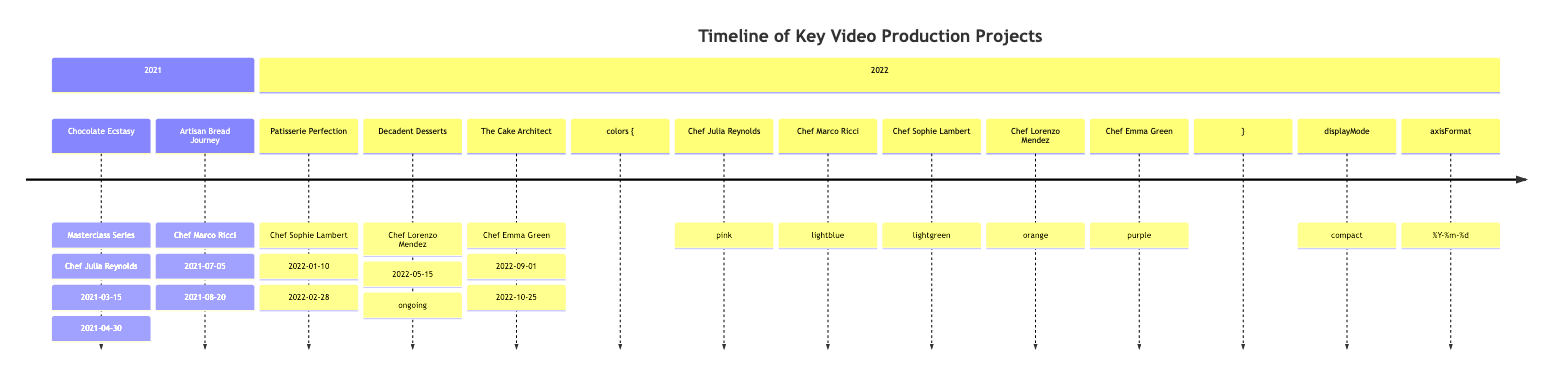what was the first project listed in the timeline? The timeline starts with the project "Chocolate Ecstasy: Masterclass Series" which is the first entry in the data provided.
Answer: Chocolate Ecstasy: Masterclass Series how many clients are represented in the timeline? The timeline lists five distinct projects, each associated with a different client. The clients are: Chef Julia Reynolds, Chef Marco Ricci, Chef Sophie Lambert, Chef Lorenzo Mendez, and Chef Emma Green, totaling five unique clients.
Answer: 5 what is the end date of the project "Patisserie Perfection"? The end date for "Patisserie Perfection" is directly mentioned in the data as February 28, 2022.
Answer: 2022-02-28 which project is ongoing? "Decadent Desserts" is noted in the time data with the current status described as "Ongoing," indicating it has not yet concluded.
Answer: Decadent Desserts who collaborated on the project "The Cake Architect"? The entry for "The Cake Architect" lists Chef Emma Green as the client involved in that specific project.
Answer: Chef Emma Green which year features the most projects in the timeline? By examining the timeframe, the year 2022 has three projects listed: "Patisserie Perfection," "Decadent Desserts," and "The Cake Architect," making it the year with the highest number of projects.
Answer: 2022 what is the overall theme of the project "Chocolate Ecstasy: Masterclass Series"? The description for "Chocolate Ecstasy: Masterclass Series" indicates that it is focused on creating gourmet chocolate desserts, highlighting its theme centered around chocolate-based culinary artistry.
Answer: gourmet chocolate desserts how long did the project "Artisan Bread Journey" last? The project "Artisan Bread Journey" started on July 5, 2021, and ended on August 20, 2021. The duration from start to end calculates to a total of 46 days.
Answer: 46 days what other projects involve Chef Lorenzo Mendez apart from "Decadent Desserts"? The timeline indicates that Chef Lorenzo Mendez only has a single project listed, which is "Decadent Desserts," meaning he does not have any additional projects in this timeline.
Answer: none 